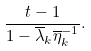Convert formula to latex. <formula><loc_0><loc_0><loc_500><loc_500>\frac { t - 1 } { 1 - \overline { \lambda } _ { k } \overline { \eta } _ { k } ^ { - 1 } } .</formula> 